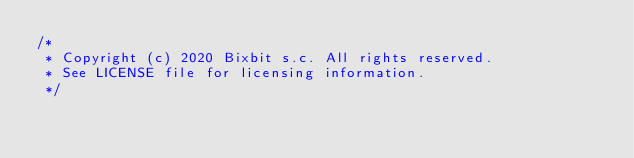Convert code to text. <code><loc_0><loc_0><loc_500><loc_500><_Java_>/*
 * Copyright (c) 2020 Bixbit s.c. All rights reserved.
 * See LICENSE file for licensing information.
 */</code> 